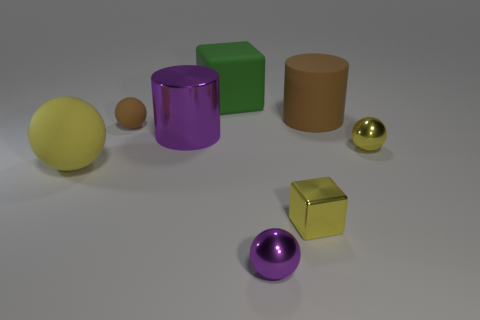There is a yellow rubber thing; is its size the same as the yellow thing that is in front of the big yellow sphere?
Your response must be concise. No. How many other objects are the same color as the large sphere?
Offer a terse response. 2. What number of other objects are the same shape as the large shiny thing?
Provide a short and direct response. 1. Do the green rubber object and the purple metallic cylinder have the same size?
Keep it short and to the point. Yes. Is there a small purple ball?
Provide a short and direct response. Yes. Are there any tiny brown cylinders made of the same material as the small purple ball?
Offer a terse response. No. There is a brown object that is the same size as the metal cube; what is its material?
Your answer should be very brief. Rubber. What number of big blue objects have the same shape as the large brown rubber thing?
Offer a very short reply. 0. There is a purple cylinder that is the same material as the tiny purple ball; what is its size?
Give a very brief answer. Large. What material is the small ball that is on the left side of the big brown thing and behind the small purple metal thing?
Offer a terse response. Rubber. 